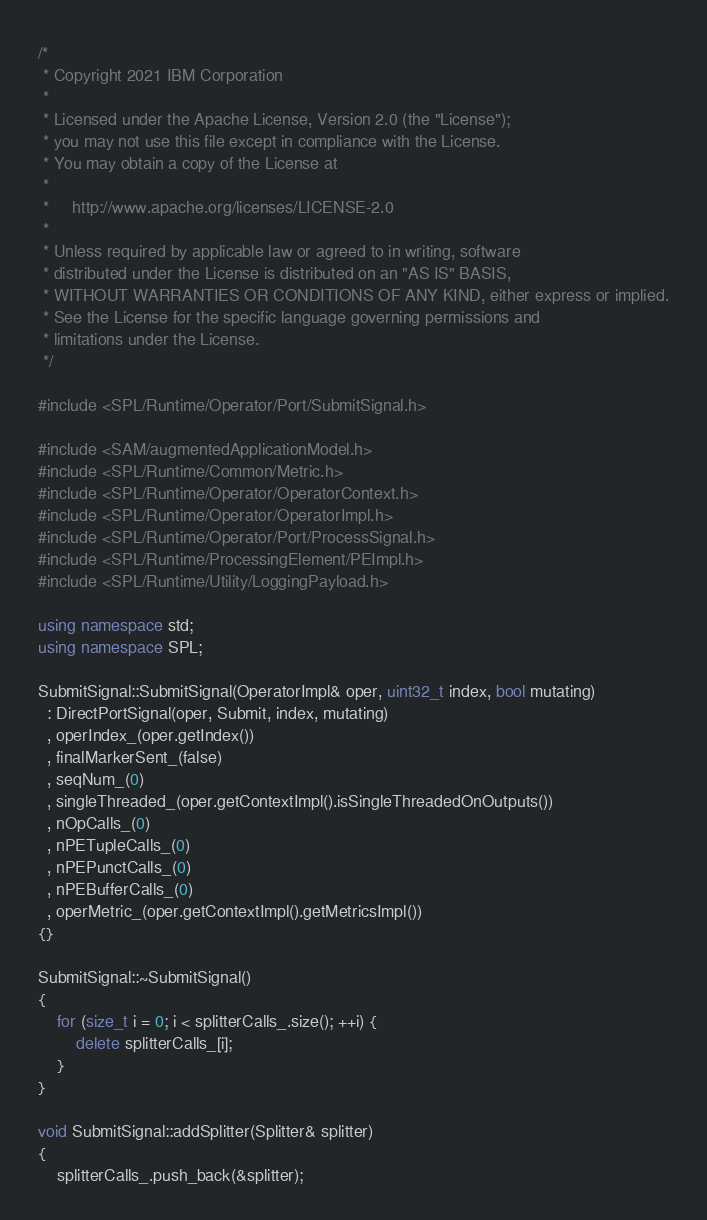<code> <loc_0><loc_0><loc_500><loc_500><_C++_>/*
 * Copyright 2021 IBM Corporation
 *
 * Licensed under the Apache License, Version 2.0 (the "License");
 * you may not use this file except in compliance with the License.
 * You may obtain a copy of the License at
 *
 *     http://www.apache.org/licenses/LICENSE-2.0
 *
 * Unless required by applicable law or agreed to in writing, software
 * distributed under the License is distributed on an "AS IS" BASIS,
 * WITHOUT WARRANTIES OR CONDITIONS OF ANY KIND, either express or implied.
 * See the License for the specific language governing permissions and
 * limitations under the License.
 */

#include <SPL/Runtime/Operator/Port/SubmitSignal.h>

#include <SAM/augmentedApplicationModel.h>
#include <SPL/Runtime/Common/Metric.h>
#include <SPL/Runtime/Operator/OperatorContext.h>
#include <SPL/Runtime/Operator/OperatorImpl.h>
#include <SPL/Runtime/Operator/Port/ProcessSignal.h>
#include <SPL/Runtime/ProcessingElement/PEImpl.h>
#include <SPL/Runtime/Utility/LoggingPayload.h>

using namespace std;
using namespace SPL;

SubmitSignal::SubmitSignal(OperatorImpl& oper, uint32_t index, bool mutating)
  : DirectPortSignal(oper, Submit, index, mutating)
  , operIndex_(oper.getIndex())
  , finalMarkerSent_(false)
  , seqNum_(0)
  , singleThreaded_(oper.getContextImpl().isSingleThreadedOnOutputs())
  , nOpCalls_(0)
  , nPETupleCalls_(0)
  , nPEPunctCalls_(0)
  , nPEBufferCalls_(0)
  , operMetric_(oper.getContextImpl().getMetricsImpl())
{}

SubmitSignal::~SubmitSignal()
{
    for (size_t i = 0; i < splitterCalls_.size(); ++i) {
        delete splitterCalls_[i];
    }
}

void SubmitSignal::addSplitter(Splitter& splitter)
{
    splitterCalls_.push_back(&splitter);</code> 